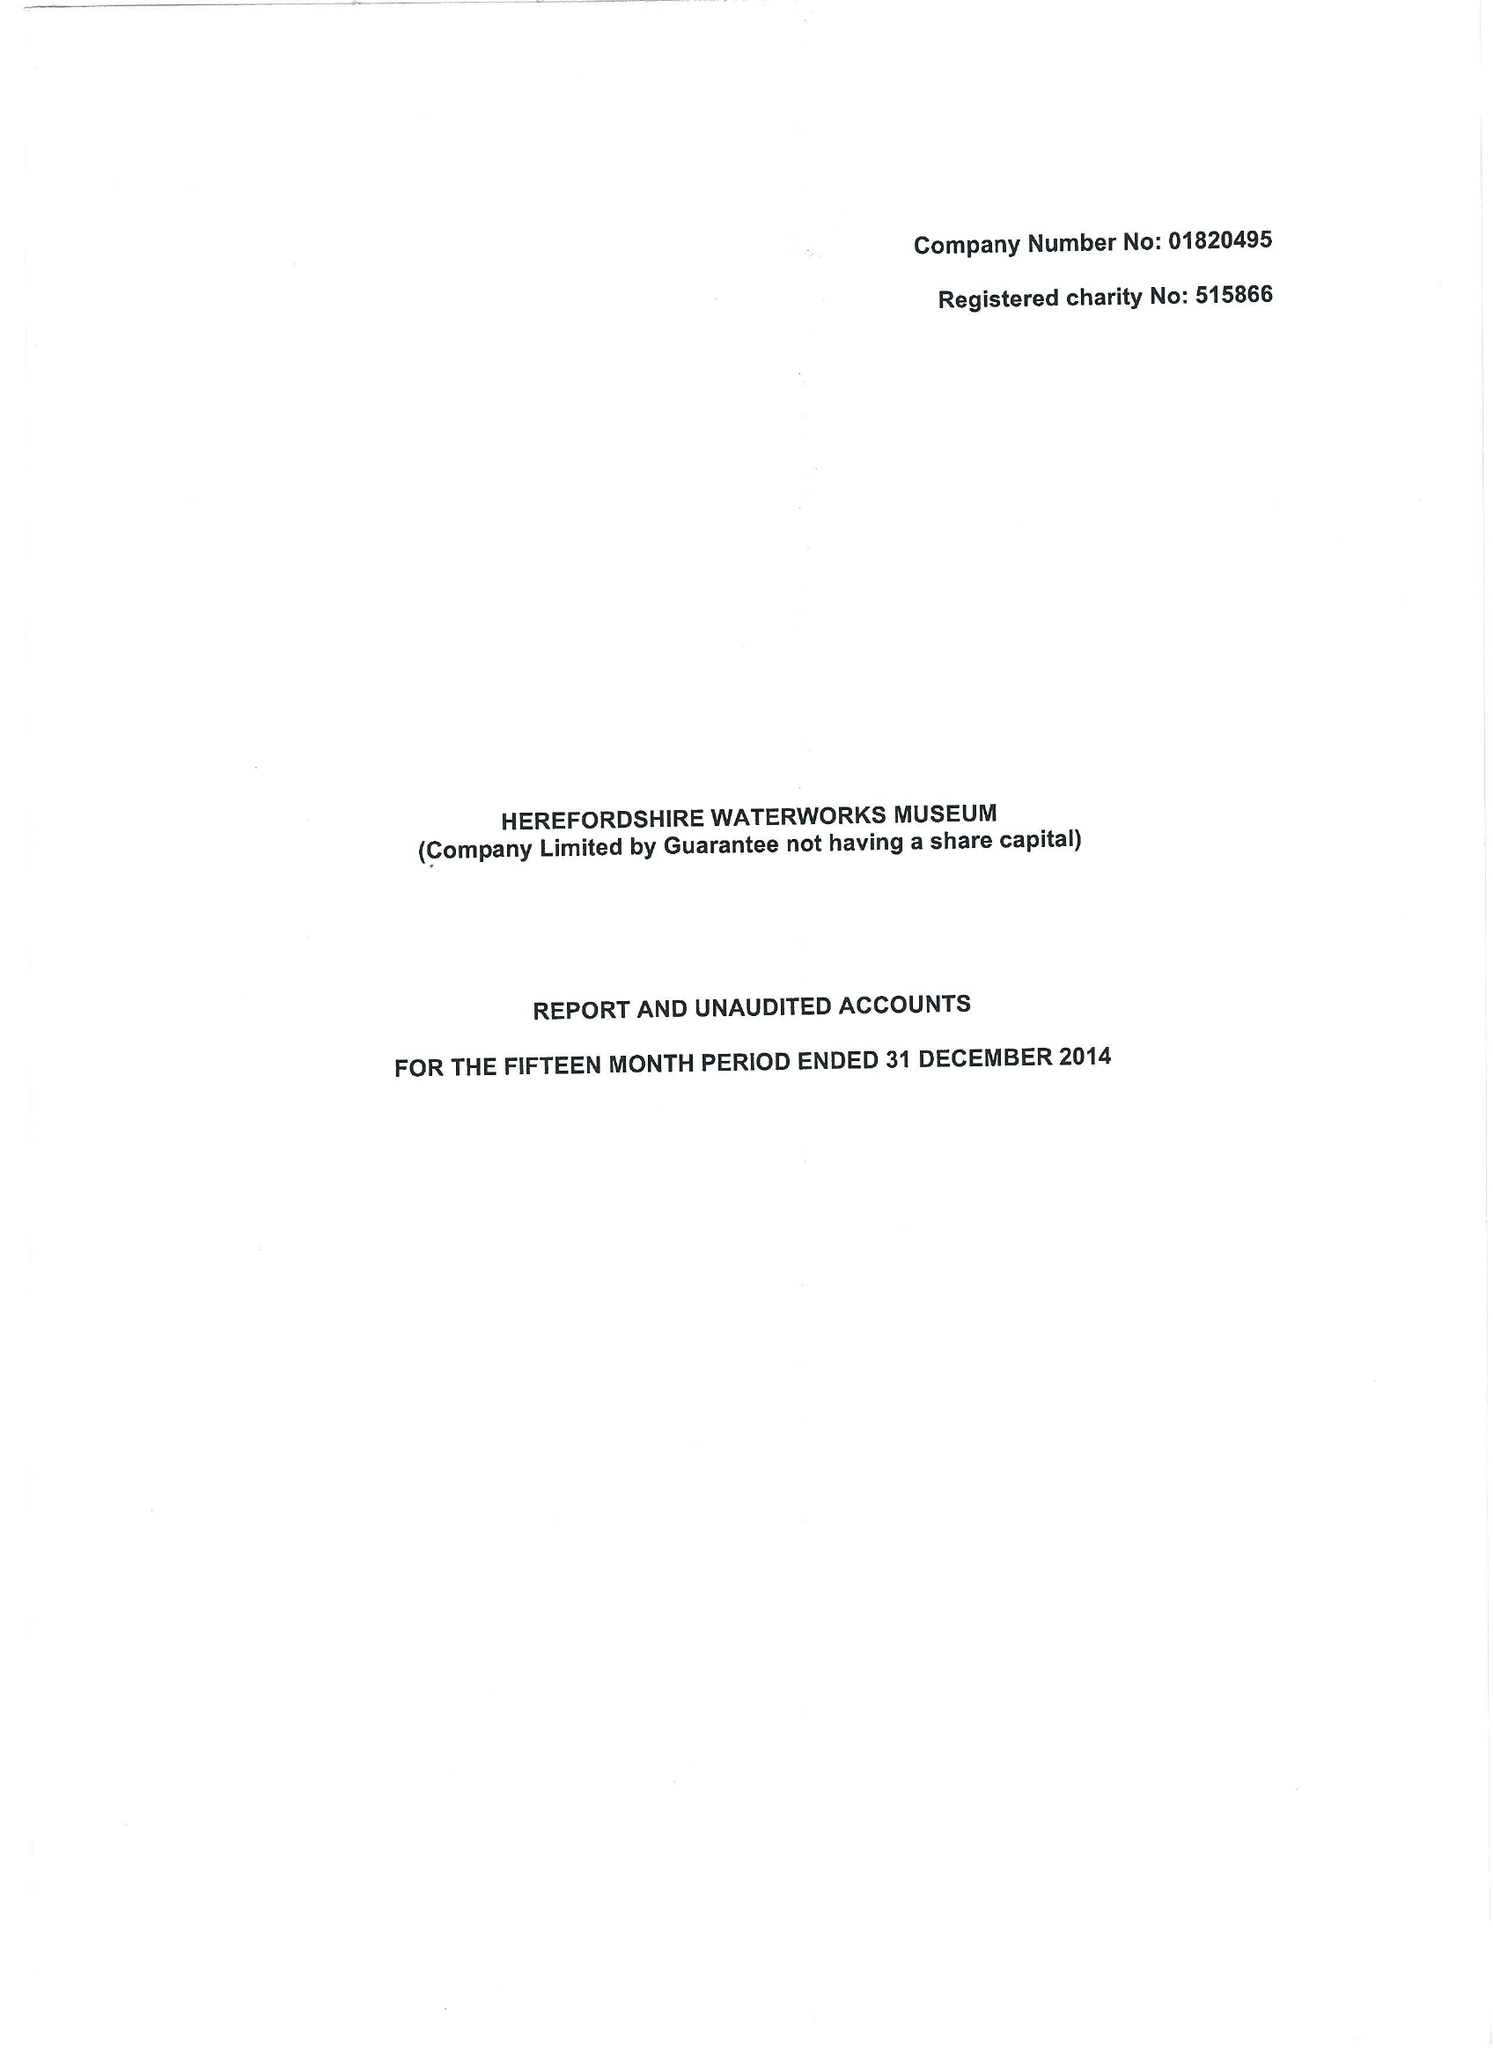What is the value for the charity_number?
Answer the question using a single word or phrase. 515866 